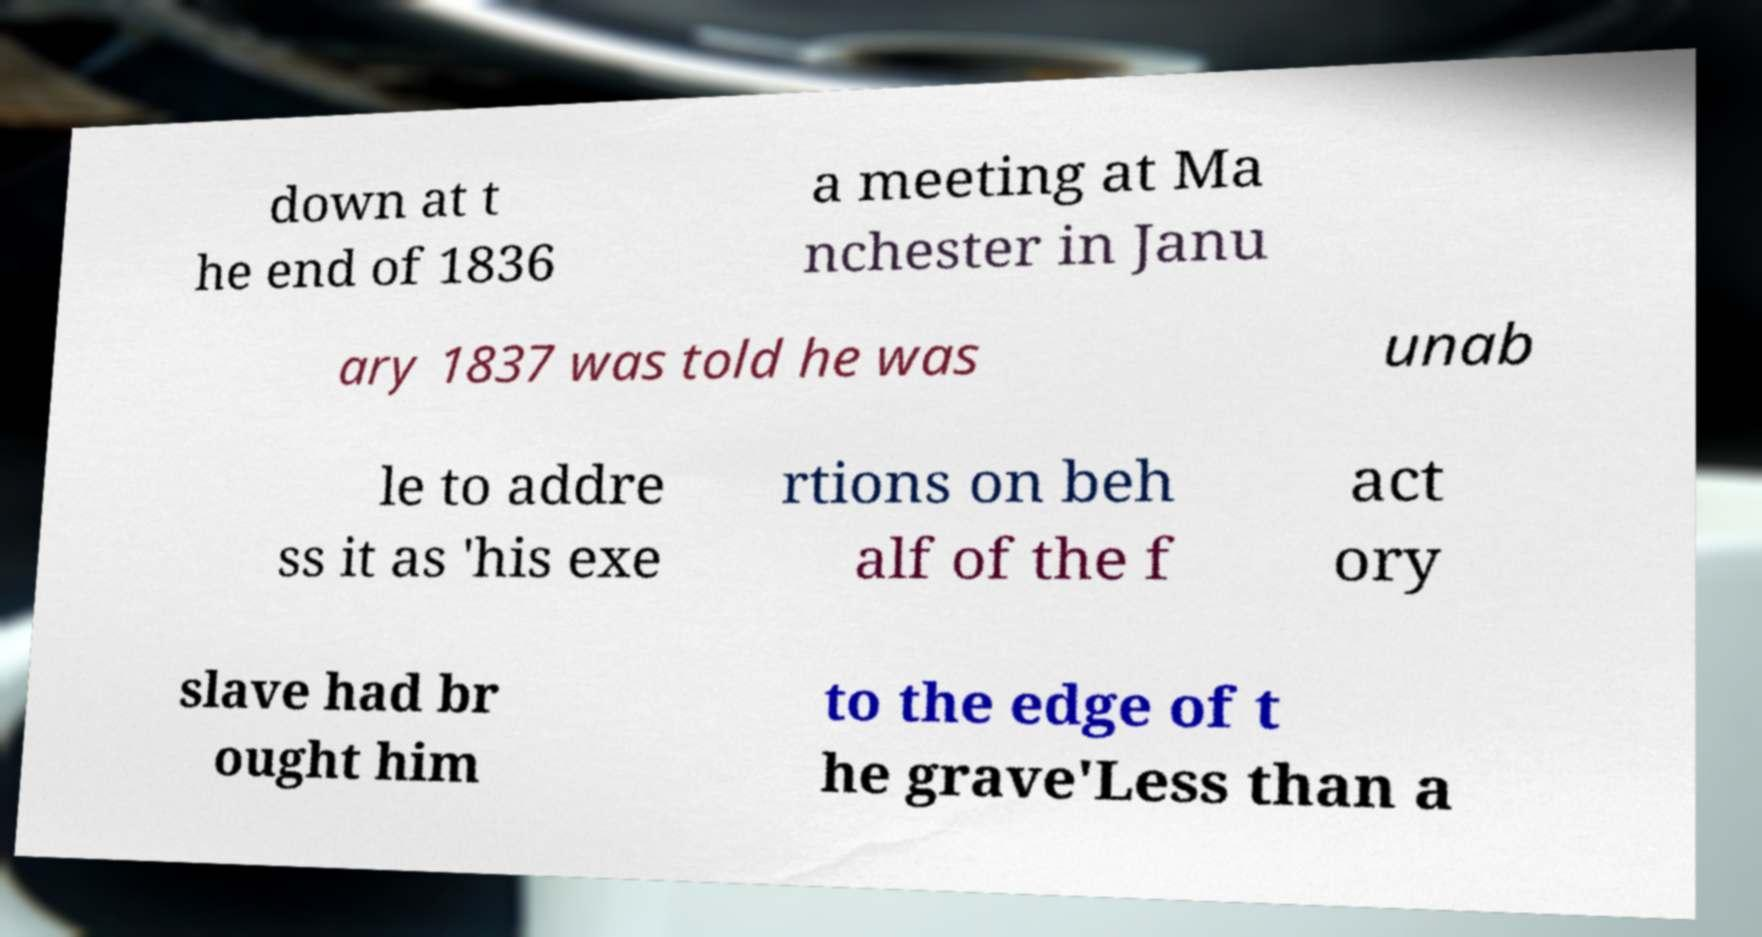Please identify and transcribe the text found in this image. down at t he end of 1836 a meeting at Ma nchester in Janu ary 1837 was told he was unab le to addre ss it as 'his exe rtions on beh alf of the f act ory slave had br ought him to the edge of t he grave'Less than a 